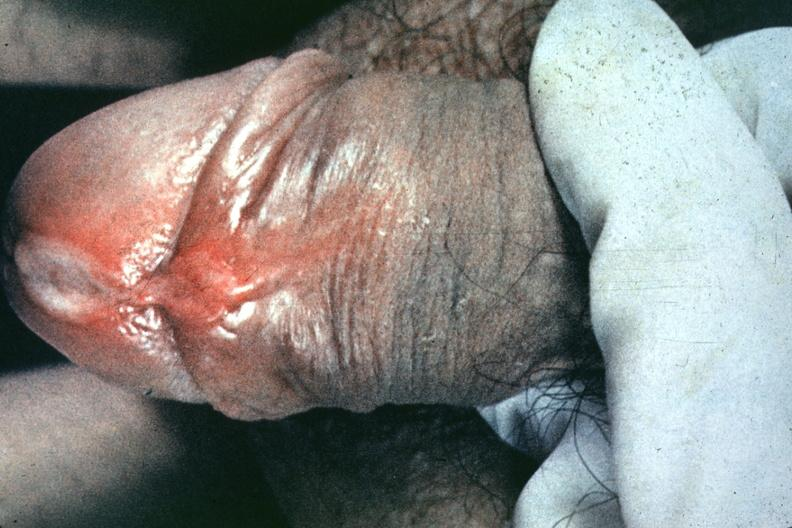what is present?
Answer the question using a single word or phrase. Penis 